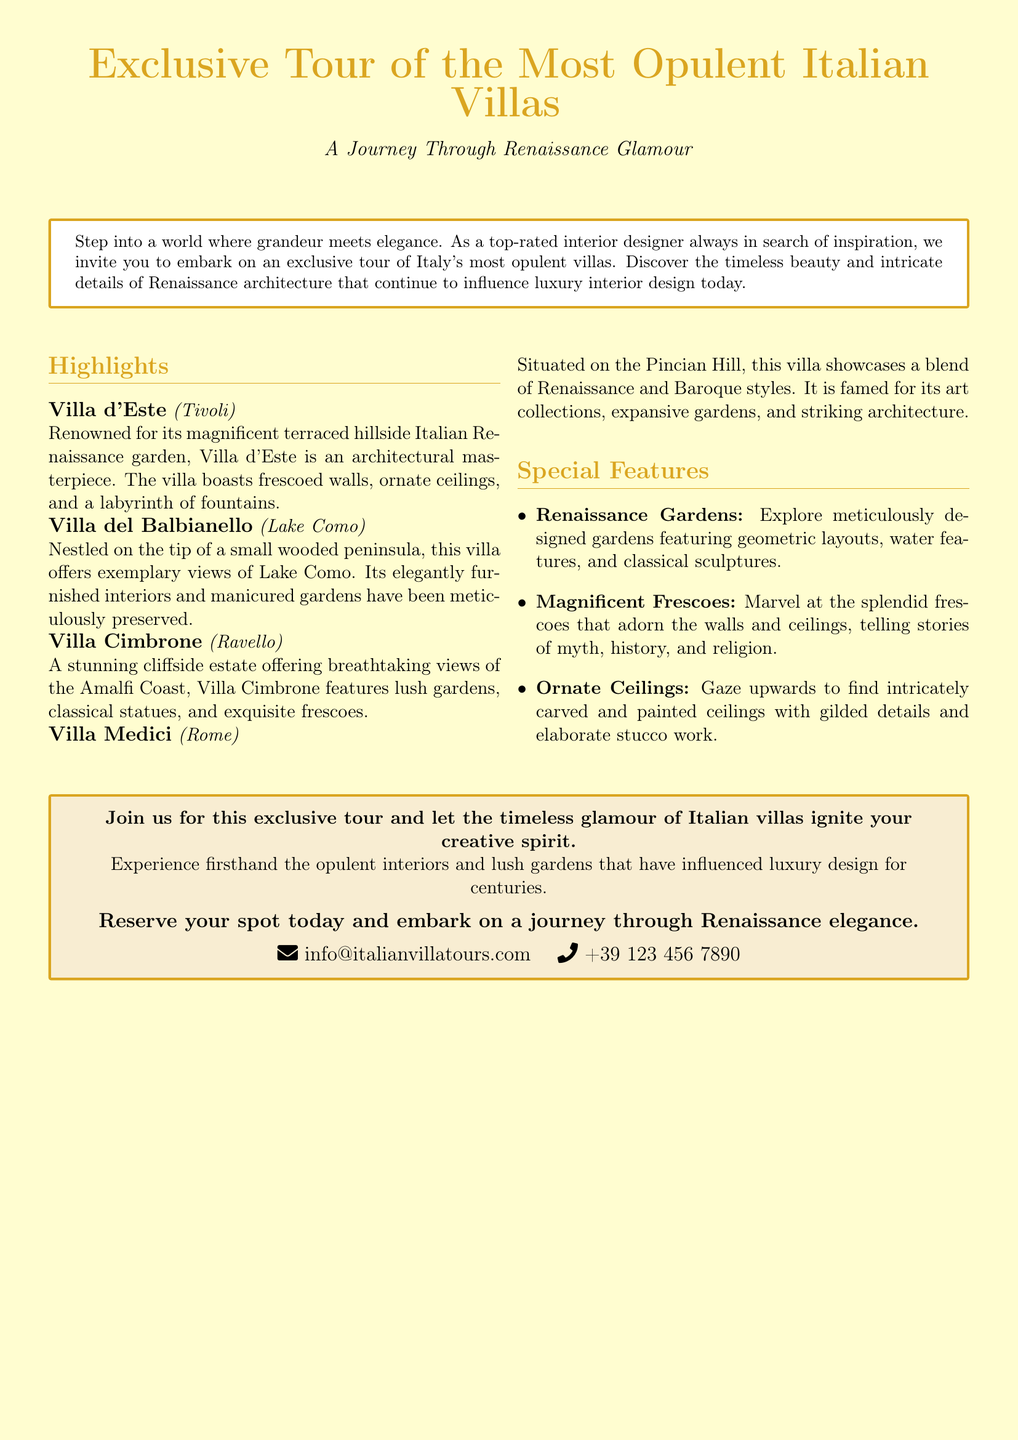What is the main theme of the tour? The theme of the tour is highlighted as "A Journey Through Renaissance Glamour."
Answer: A Journey Through Renaissance Glamour Which villa is located in Tivoli? The villa entry specifically states that Villa d'Este is located in Tivoli.
Answer: Villa d'Este How many villas are highlighted in the advertisement? The document lists four villas under the Highlights section.
Answer: Four What feature is associated with Villa del Balbianello? The description mentions that Villa del Balbianello offers exemplary views of Lake Como.
Answer: Exemplary views of Lake Como What type of gardens will be explored during the tour? The document details the special feature that involves exploring meticulously designed Renaissance gardens.
Answer: Renaissance gardens What is the contact email provided for reservations? The advertisement includes an email for contact, which is specified in the box at the bottom.
Answer: info@italianvillatours.com What architectural styles are showcased in Villa Medici? The architectural styles mentioned in relation to Villa Medici are a blend of Renaissance and Baroque styles.
Answer: Renaissance and Baroque What type of ceilings can be seen in the villas? The document describes the ceilings as intricately carved and painted with gilded details.
Answer: Ornate Ceilings What is the main intent of the advertisement? The intent is to invite individuals to join for an exclusive tour and inspire creativity.
Answer: Inspire creativity 